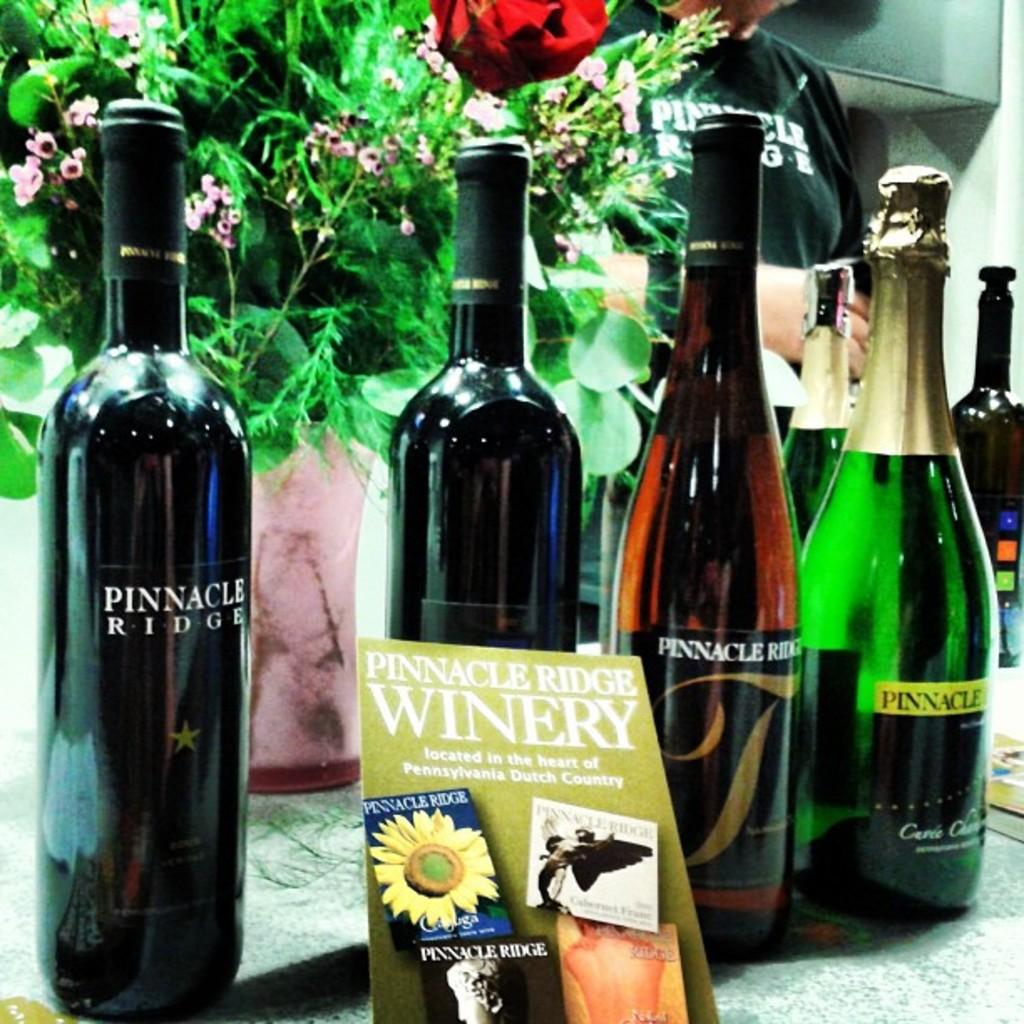<image>
Provide a brief description of the given image. Bottles of Pinnacle Ridge wine and a Pinnacle Ridge winery sign 